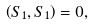Convert formula to latex. <formula><loc_0><loc_0><loc_500><loc_500>\left ( S _ { 1 } , S _ { 1 } \right ) = 0 ,</formula> 